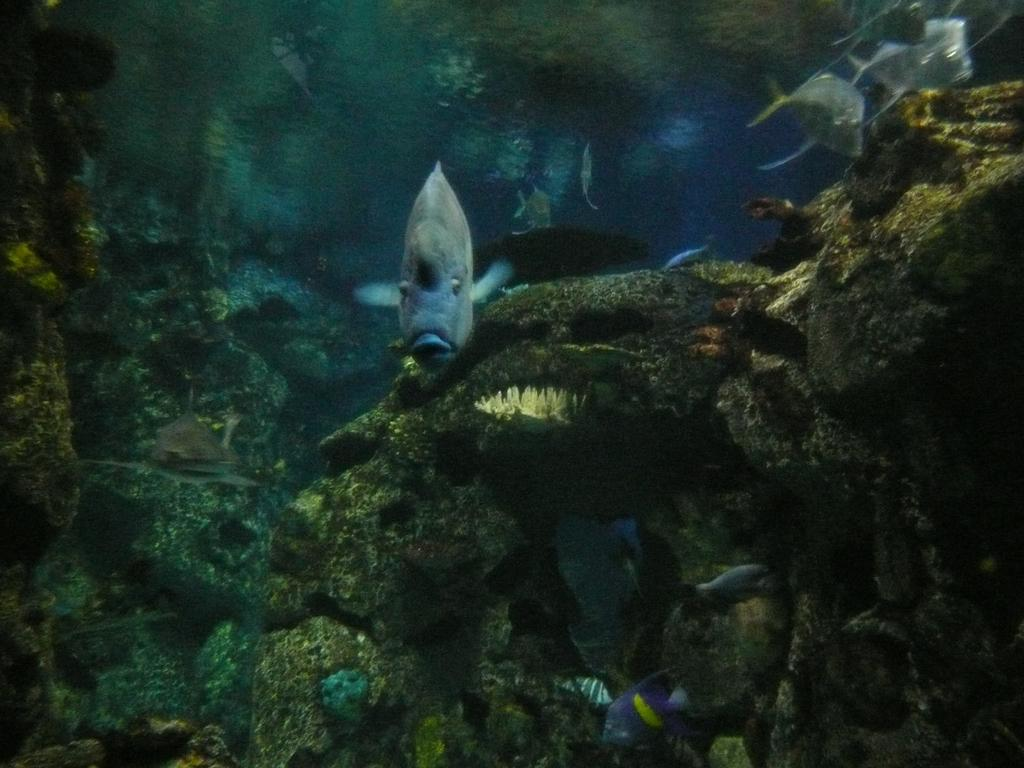What type of animals can be seen in the image? There are fishes in the water. What other elements can be found in the water besides the fishes? There are water plants in the image. What type of butter can be seen floating on the water in the image? There is no butter present in the image; it features fishes and water plants in the water. Can you see a kitty swimming with the fishes in the image? There is no kitty present in the image; it only shows fishes and water plants in the water. 